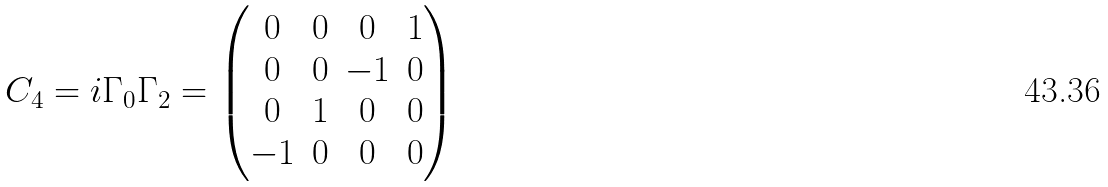Convert formula to latex. <formula><loc_0><loc_0><loc_500><loc_500>C _ { 4 } = i \Gamma _ { 0 } \Gamma _ { 2 } = \begin{pmatrix} 0 & 0 & 0 & 1 \\ 0 & 0 & - 1 & 0 \\ 0 & 1 & 0 & 0 \\ - 1 & 0 & 0 & 0 \end{pmatrix}</formula> 